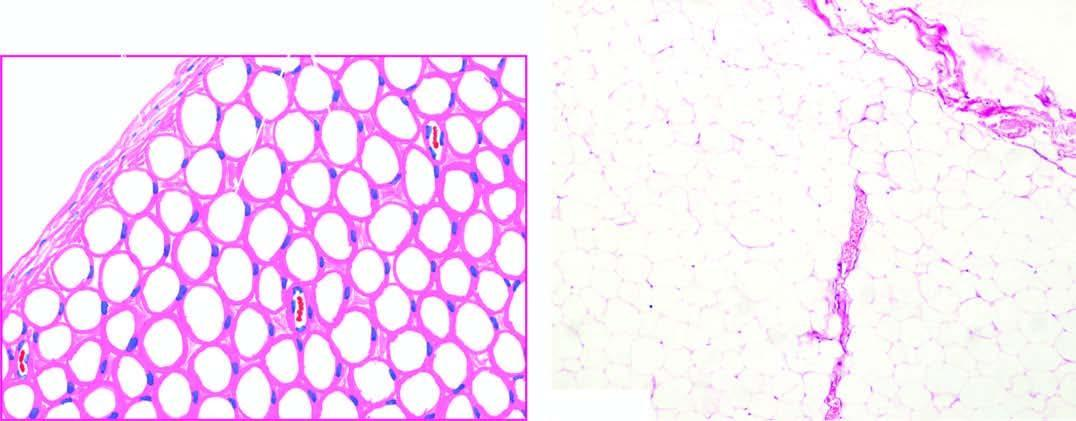what shows a thin capsule and underlying lobules of mature adipose cells separated by delicate fibrous septa?
Answer the question using a single word or phrase. Tumour 